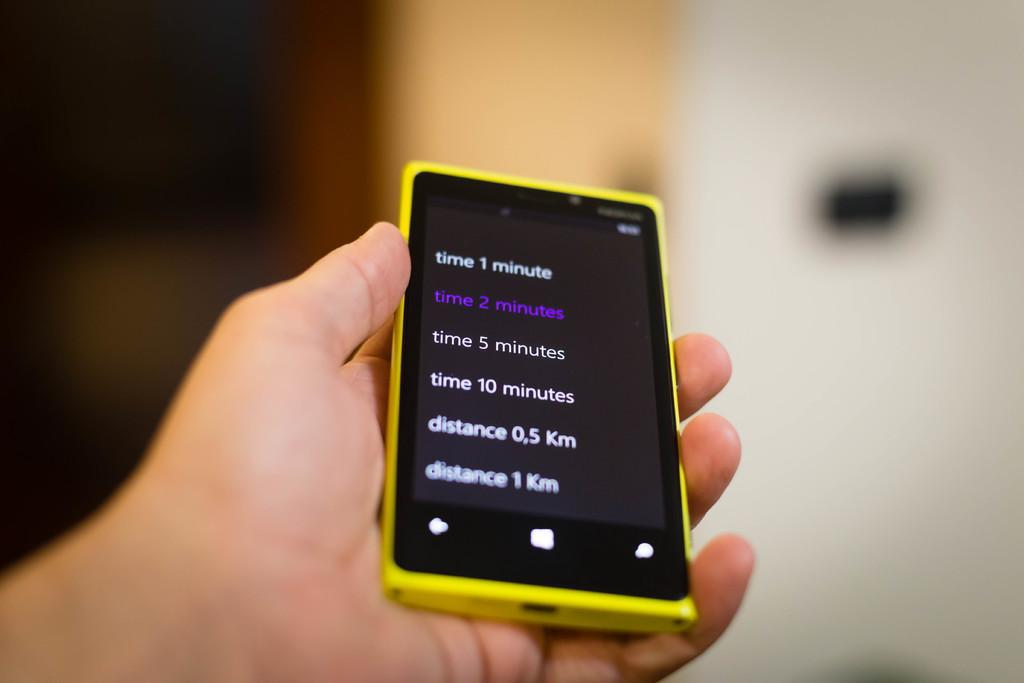<image>
Create a compact narrative representing the image presented. A hand holding a cell phone with the words time one minute at the top of the screen. 